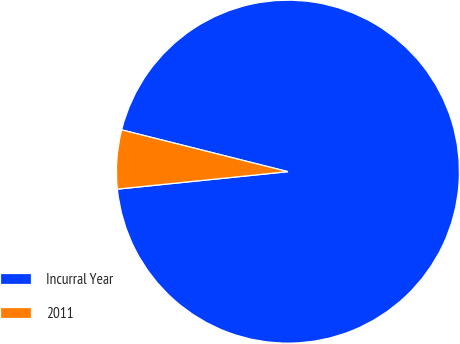Convert chart to OTSL. <chart><loc_0><loc_0><loc_500><loc_500><pie_chart><fcel>Incurral Year<fcel>2011<nl><fcel>94.46%<fcel>5.54%<nl></chart> 